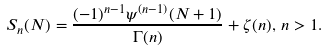<formula> <loc_0><loc_0><loc_500><loc_500>S _ { n } ( N ) = \frac { ( - 1 ) ^ { n - 1 } \psi ^ { ( n - 1 ) } ( N + 1 ) } { \Gamma ( n ) } + \zeta ( n ) , \, n > 1 .</formula> 